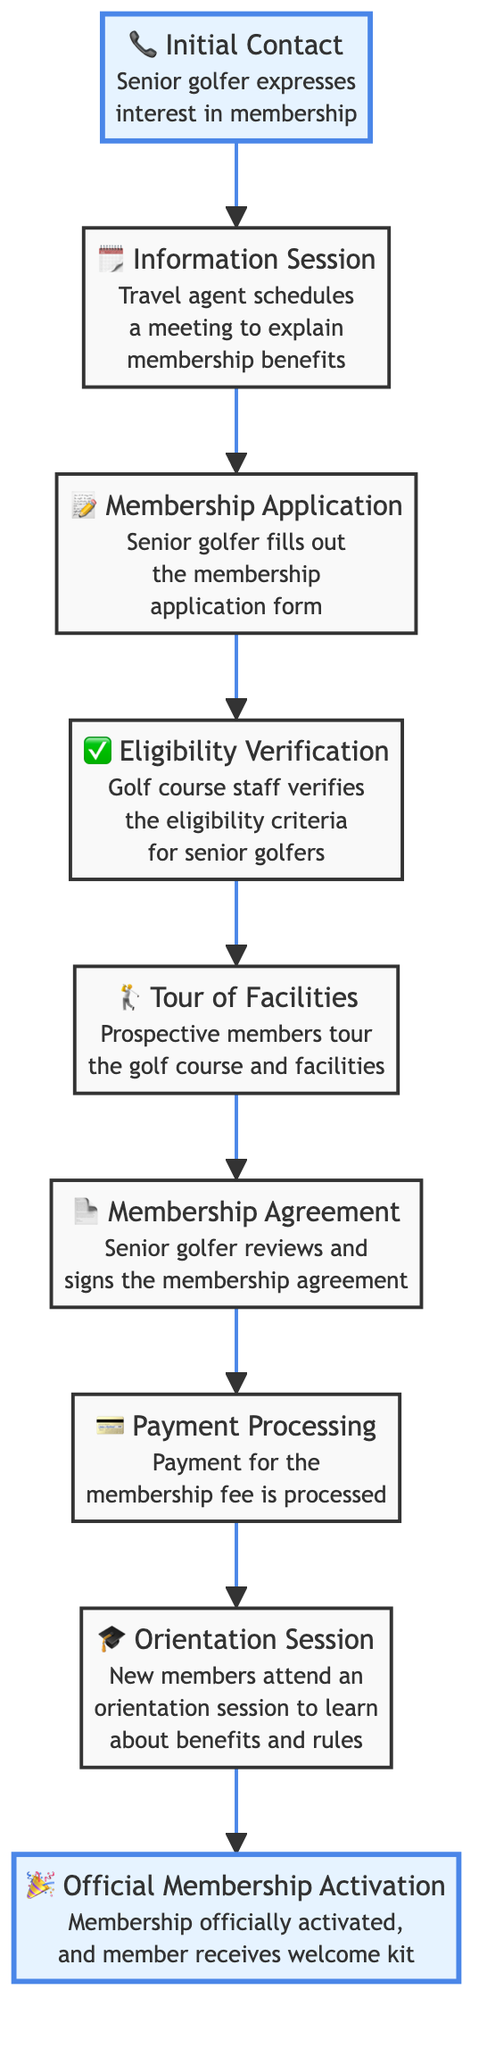What’s the first step in the membership enrollment process? The diagram shows that the first step is "Initial Contact." This is the starting point of the flow chart where the process begins.
Answer: Initial Contact How many steps are there in total in the enrollment process? By counting the nodes in the flow chart, there are a total of nine distinct steps listed from Initial Contact to Official Membership Activation.
Answer: 9 Which step follows the "Tour of Facilities"? Looking at the flow chart, the step that comes immediately after "Tour of Facilities" is "Membership Agreement." This shows the sequential flow of the process.
Answer: Membership Agreement What action is described in the "Payment Processing" step? The flow chart indicates that during the "Payment Processing" step, the action taken is processing the payment for the membership fee. This step is crucial for completing the enrollment.
Answer: Payment for the membership fee is processed What is the last step in the enrollment process? The last step indicated in the flow chart is "Official Membership Activation." This signifies the conclusion of the enrollment process and the formal activation of the membership.
Answer: Official Membership Activation Which step requires the prospective member to fill out a form? Referring to the diagram, the step that requires the senior golfer to fill out a form is the "Membership Application." This is an essential part of the enrollment process.
Answer: Membership Application How many steps are there between "Information Session" and "Orientation Session"? Counting the steps between "Information Session" and "Orientation Session," we find there are five steps, which are Membership Application, Eligibility Verification, Tour of Facilities, Membership Agreement, and Payment Processing.
Answer: 5 What happens immediately before "Official Membership Activation"? The diagram shows that immediately before "Official Membership Activation," the step is "Orientation Session." This indicates that members must attend an orientation session before their membership is officially activated.
Answer: Orientation Session What type of meeting is scheduled in the "Information Session"? In the "Information Session" step, a meeting is scheduled to explain the membership benefits to the senior golfers. This informational step is critical for their understanding of the membership.
Answer: A meeting to explain membership benefits 